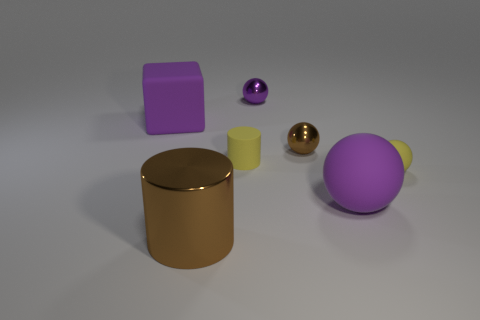There is a matte ball that is the same color as the large matte cube; what is its size?
Give a very brief answer. Large. Are the object that is on the left side of the large brown metallic cylinder and the tiny brown object made of the same material?
Offer a terse response. No. Are there fewer tiny purple metal things to the right of the small yellow sphere than small purple objects?
Your response must be concise. Yes. The matte cylinder that is the same size as the purple metal ball is what color?
Your answer should be very brief. Yellow. What number of tiny yellow objects are the same shape as the big brown thing?
Your answer should be very brief. 1. There is a metallic ball in front of the purple block; what color is it?
Offer a very short reply. Brown. What number of rubber things are either brown objects or large brown objects?
Ensure brevity in your answer.  0. The matte object that is the same color as the big ball is what shape?
Offer a terse response. Cube. How many purple blocks have the same size as the purple matte sphere?
Keep it short and to the point. 1. There is a large thing that is to the left of the tiny rubber cylinder and behind the large brown thing; what color is it?
Your answer should be very brief. Purple. 